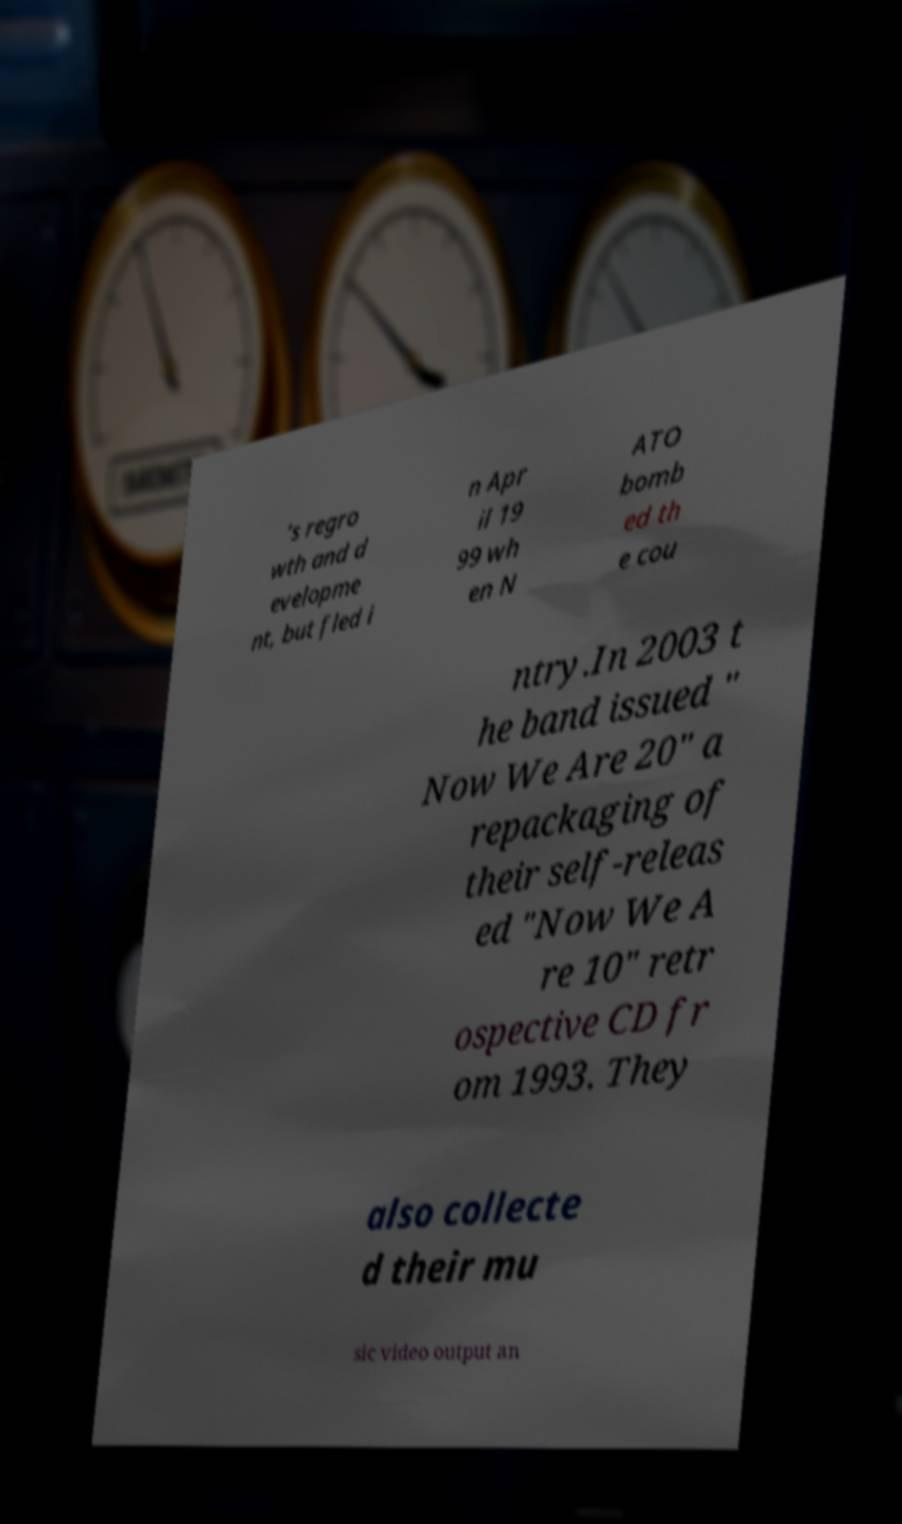For documentation purposes, I need the text within this image transcribed. Could you provide that? ’s regro wth and d evelopme nt, but fled i n Apr il 19 99 wh en N ATO bomb ed th e cou ntry.In 2003 t he band issued " Now We Are 20" a repackaging of their self-releas ed "Now We A re 10" retr ospective CD fr om 1993. They also collecte d their mu sic video output an 